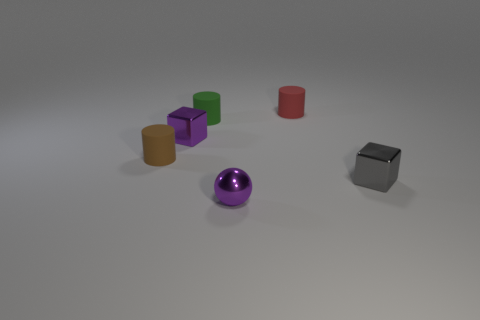What is the shape of the object that is the same color as the small metal sphere? The object that shares its color with the small metal sphere appears to be a cube. This cube, cast in the same reflective purple hue as the sphere, aligns with the standard geometrical definition of a cube featuring six square faces, all of the same size. 